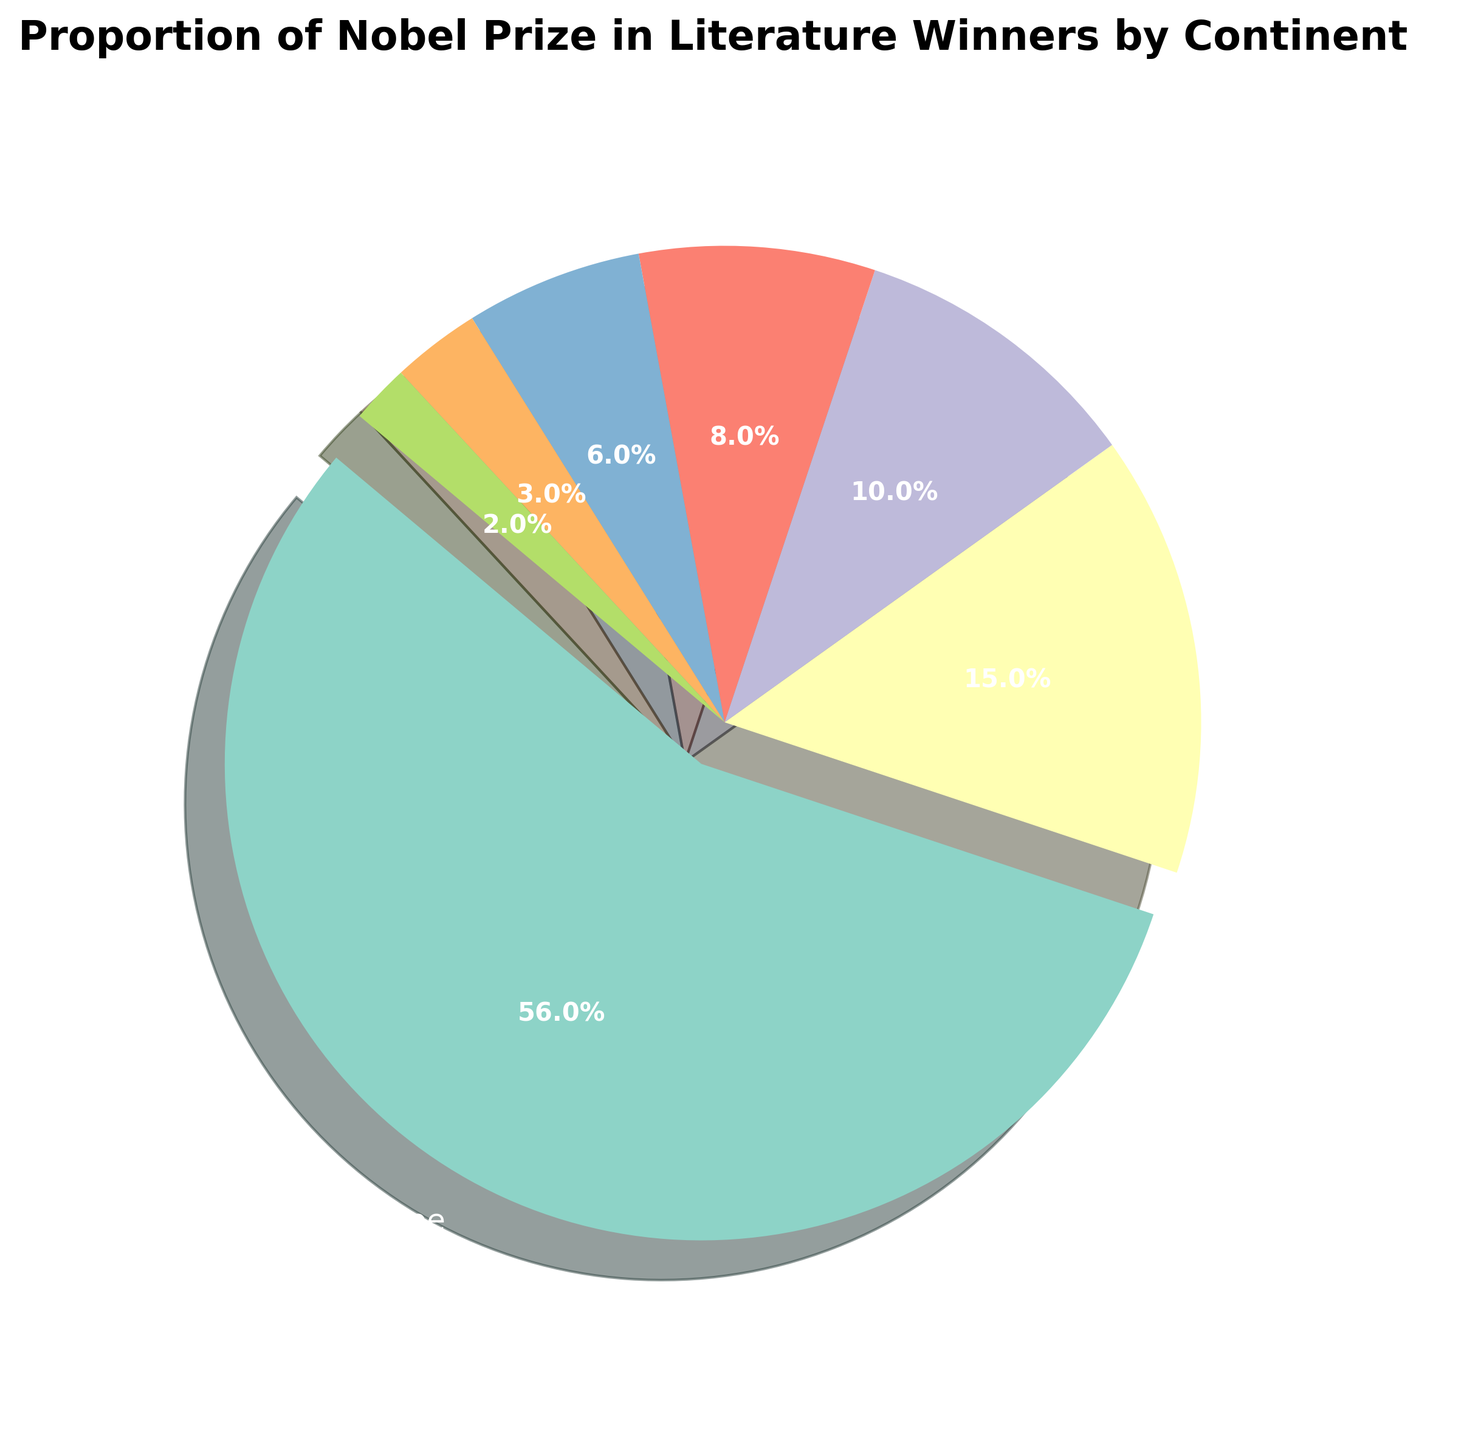What proportion of Nobel Prize winners in Literature are from Europe? By looking at the pie chart, we can observe that the slice representing Europe is labeled with "56.0%." This indicates that 56% of the winners come from Europe.
Answer: 56% Which continent has the least proportion of Nobel Prize winners in Literature? The pie chart shows that "Multiple Continents" has the smallest slice labeled with "2.0%," indicating it has the least proportion of winners.
Answer: Multiple Continents How does the proportion of winners from North America compare to those from Asia? The pie chart indicates that North America has a proportion of 15%, while Asia has 10%. By comparing these two values, we can see that North America has a higher proportion of winners than Asia.
Answer: North America has a higher proportion What is the combined proportion of Nobel Prize winners in Literature from South America and Africa? By summing the proportions for South America and Africa, which are 8% and 6% respectively, we get 8 + 6 = 14%.
Answer: 14% How many times larger is the proportion of European winners compared to Oceania winners? The European proportion is 56%, and the Oceania proportion is 3%. We divide 56 by 3 to find out: 56 / 3 ≈ 18.67 times larger.
Answer: 18.67 Which continents have a proportion of winners in the single digits? The pie chart shows that Asia (10%), South America (8%), Africa (6%), Oceania (3%), and Multiple Continents (2%) have proportions in single digits. However, 10% is not a single digit, so Asia is excluded.
Answer: South America, Africa, Oceania, Multiple Continents What is the difference in the proportion of Nobel Prize winners between Europe and North America? By subtracting the proportion of North America (15%) from Europe (56%), we get 56 - 15 = 41%.
Answer: 41% Identify all the continents with proportions greater than 5%. Observing the pie chart, we can see that Europe (56%), North America (15%), Asia (10%), and South America (8%) each have proportions greater than 5%.
Answer: Europe, North America, Asia, South America 